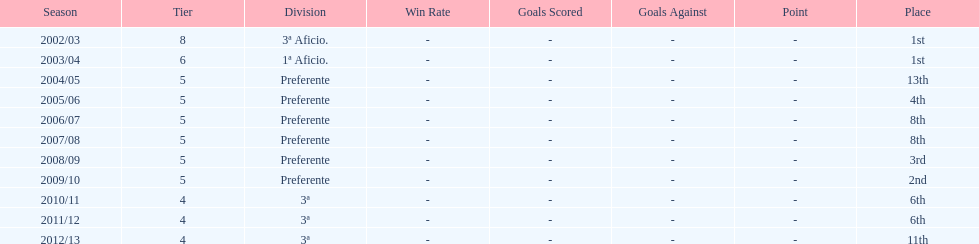How many years was the team in the 3 a division? 4. 